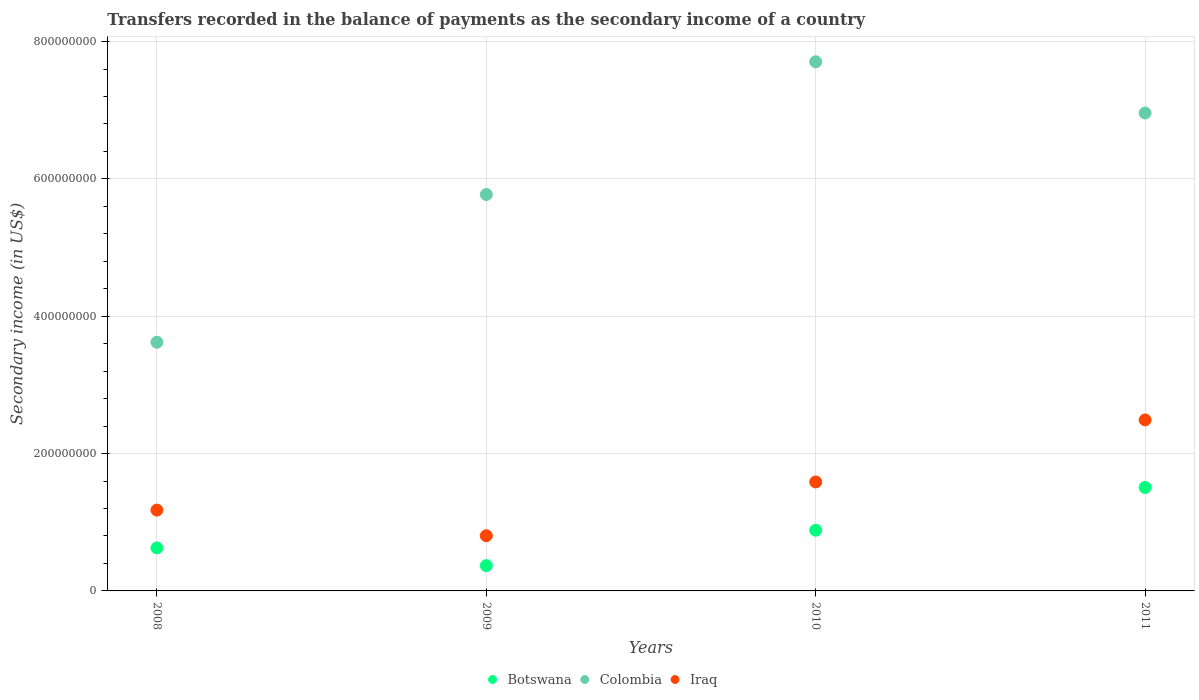Is the number of dotlines equal to the number of legend labels?
Offer a very short reply. Yes. What is the secondary income of in Botswana in 2008?
Your response must be concise. 6.26e+07. Across all years, what is the maximum secondary income of in Colombia?
Offer a terse response. 7.71e+08. Across all years, what is the minimum secondary income of in Iraq?
Your answer should be compact. 8.04e+07. In which year was the secondary income of in Botswana maximum?
Give a very brief answer. 2011. In which year was the secondary income of in Botswana minimum?
Ensure brevity in your answer.  2009. What is the total secondary income of in Iraq in the graph?
Provide a succinct answer. 6.06e+08. What is the difference between the secondary income of in Iraq in 2008 and that in 2010?
Offer a very short reply. -4.10e+07. What is the difference between the secondary income of in Colombia in 2011 and the secondary income of in Botswana in 2010?
Keep it short and to the point. 6.07e+08. What is the average secondary income of in Botswana per year?
Ensure brevity in your answer.  8.46e+07. In the year 2008, what is the difference between the secondary income of in Colombia and secondary income of in Botswana?
Offer a terse response. 3.00e+08. What is the ratio of the secondary income of in Botswana in 2008 to that in 2010?
Provide a succinct answer. 0.71. What is the difference between the highest and the second highest secondary income of in Colombia?
Make the answer very short. 7.46e+07. What is the difference between the highest and the lowest secondary income of in Iraq?
Offer a terse response. 1.69e+08. In how many years, is the secondary income of in Iraq greater than the average secondary income of in Iraq taken over all years?
Offer a very short reply. 2. Is the sum of the secondary income of in Colombia in 2008 and 2011 greater than the maximum secondary income of in Botswana across all years?
Offer a very short reply. Yes. Does the secondary income of in Iraq monotonically increase over the years?
Offer a very short reply. No. How many dotlines are there?
Provide a succinct answer. 3. How many years are there in the graph?
Give a very brief answer. 4. What is the difference between two consecutive major ticks on the Y-axis?
Offer a terse response. 2.00e+08. Are the values on the major ticks of Y-axis written in scientific E-notation?
Your answer should be very brief. No. Does the graph contain any zero values?
Give a very brief answer. No. Where does the legend appear in the graph?
Your response must be concise. Bottom center. What is the title of the graph?
Offer a very short reply. Transfers recorded in the balance of payments as the secondary income of a country. Does "Iran" appear as one of the legend labels in the graph?
Your response must be concise. No. What is the label or title of the Y-axis?
Provide a short and direct response. Secondary income (in US$). What is the Secondary income (in US$) of Botswana in 2008?
Ensure brevity in your answer.  6.26e+07. What is the Secondary income (in US$) of Colombia in 2008?
Keep it short and to the point. 3.62e+08. What is the Secondary income (in US$) in Iraq in 2008?
Your response must be concise. 1.18e+08. What is the Secondary income (in US$) in Botswana in 2009?
Provide a short and direct response. 3.68e+07. What is the Secondary income (in US$) of Colombia in 2009?
Your answer should be very brief. 5.77e+08. What is the Secondary income (in US$) of Iraq in 2009?
Your response must be concise. 8.04e+07. What is the Secondary income (in US$) of Botswana in 2010?
Keep it short and to the point. 8.84e+07. What is the Secondary income (in US$) in Colombia in 2010?
Your answer should be compact. 7.71e+08. What is the Secondary income (in US$) of Iraq in 2010?
Ensure brevity in your answer.  1.59e+08. What is the Secondary income (in US$) in Botswana in 2011?
Your answer should be very brief. 1.51e+08. What is the Secondary income (in US$) in Colombia in 2011?
Your answer should be compact. 6.96e+08. What is the Secondary income (in US$) in Iraq in 2011?
Make the answer very short. 2.49e+08. Across all years, what is the maximum Secondary income (in US$) of Botswana?
Offer a terse response. 1.51e+08. Across all years, what is the maximum Secondary income (in US$) in Colombia?
Provide a succinct answer. 7.71e+08. Across all years, what is the maximum Secondary income (in US$) in Iraq?
Your answer should be very brief. 2.49e+08. Across all years, what is the minimum Secondary income (in US$) of Botswana?
Ensure brevity in your answer.  3.68e+07. Across all years, what is the minimum Secondary income (in US$) in Colombia?
Offer a very short reply. 3.62e+08. Across all years, what is the minimum Secondary income (in US$) in Iraq?
Make the answer very short. 8.04e+07. What is the total Secondary income (in US$) in Botswana in the graph?
Your response must be concise. 3.39e+08. What is the total Secondary income (in US$) of Colombia in the graph?
Offer a very short reply. 2.41e+09. What is the total Secondary income (in US$) of Iraq in the graph?
Make the answer very short. 6.06e+08. What is the difference between the Secondary income (in US$) in Botswana in 2008 and that in 2009?
Ensure brevity in your answer.  2.58e+07. What is the difference between the Secondary income (in US$) in Colombia in 2008 and that in 2009?
Give a very brief answer. -2.15e+08. What is the difference between the Secondary income (in US$) of Iraq in 2008 and that in 2009?
Make the answer very short. 3.73e+07. What is the difference between the Secondary income (in US$) of Botswana in 2008 and that in 2010?
Your response must be concise. -2.58e+07. What is the difference between the Secondary income (in US$) of Colombia in 2008 and that in 2010?
Offer a terse response. -4.08e+08. What is the difference between the Secondary income (in US$) of Iraq in 2008 and that in 2010?
Your answer should be very brief. -4.10e+07. What is the difference between the Secondary income (in US$) of Botswana in 2008 and that in 2011?
Ensure brevity in your answer.  -8.80e+07. What is the difference between the Secondary income (in US$) in Colombia in 2008 and that in 2011?
Provide a succinct answer. -3.34e+08. What is the difference between the Secondary income (in US$) in Iraq in 2008 and that in 2011?
Ensure brevity in your answer.  -1.31e+08. What is the difference between the Secondary income (in US$) in Botswana in 2009 and that in 2010?
Your response must be concise. -5.16e+07. What is the difference between the Secondary income (in US$) in Colombia in 2009 and that in 2010?
Give a very brief answer. -1.93e+08. What is the difference between the Secondary income (in US$) in Iraq in 2009 and that in 2010?
Ensure brevity in your answer.  -7.83e+07. What is the difference between the Secondary income (in US$) of Botswana in 2009 and that in 2011?
Provide a short and direct response. -1.14e+08. What is the difference between the Secondary income (in US$) of Colombia in 2009 and that in 2011?
Your answer should be very brief. -1.19e+08. What is the difference between the Secondary income (in US$) in Iraq in 2009 and that in 2011?
Offer a very short reply. -1.69e+08. What is the difference between the Secondary income (in US$) of Botswana in 2010 and that in 2011?
Provide a succinct answer. -6.22e+07. What is the difference between the Secondary income (in US$) in Colombia in 2010 and that in 2011?
Your answer should be very brief. 7.46e+07. What is the difference between the Secondary income (in US$) of Iraq in 2010 and that in 2011?
Make the answer very short. -9.03e+07. What is the difference between the Secondary income (in US$) of Botswana in 2008 and the Secondary income (in US$) of Colombia in 2009?
Make the answer very short. -5.15e+08. What is the difference between the Secondary income (in US$) of Botswana in 2008 and the Secondary income (in US$) of Iraq in 2009?
Give a very brief answer. -1.78e+07. What is the difference between the Secondary income (in US$) in Colombia in 2008 and the Secondary income (in US$) in Iraq in 2009?
Keep it short and to the point. 2.82e+08. What is the difference between the Secondary income (in US$) in Botswana in 2008 and the Secondary income (in US$) in Colombia in 2010?
Offer a very short reply. -7.08e+08. What is the difference between the Secondary income (in US$) in Botswana in 2008 and the Secondary income (in US$) in Iraq in 2010?
Provide a succinct answer. -9.61e+07. What is the difference between the Secondary income (in US$) in Colombia in 2008 and the Secondary income (in US$) in Iraq in 2010?
Ensure brevity in your answer.  2.03e+08. What is the difference between the Secondary income (in US$) of Botswana in 2008 and the Secondary income (in US$) of Colombia in 2011?
Ensure brevity in your answer.  -6.33e+08. What is the difference between the Secondary income (in US$) in Botswana in 2008 and the Secondary income (in US$) in Iraq in 2011?
Give a very brief answer. -1.86e+08. What is the difference between the Secondary income (in US$) of Colombia in 2008 and the Secondary income (in US$) of Iraq in 2011?
Your answer should be compact. 1.13e+08. What is the difference between the Secondary income (in US$) of Botswana in 2009 and the Secondary income (in US$) of Colombia in 2010?
Provide a short and direct response. -7.34e+08. What is the difference between the Secondary income (in US$) in Botswana in 2009 and the Secondary income (in US$) in Iraq in 2010?
Provide a short and direct response. -1.22e+08. What is the difference between the Secondary income (in US$) in Colombia in 2009 and the Secondary income (in US$) in Iraq in 2010?
Your response must be concise. 4.19e+08. What is the difference between the Secondary income (in US$) in Botswana in 2009 and the Secondary income (in US$) in Colombia in 2011?
Keep it short and to the point. -6.59e+08. What is the difference between the Secondary income (in US$) in Botswana in 2009 and the Secondary income (in US$) in Iraq in 2011?
Provide a short and direct response. -2.12e+08. What is the difference between the Secondary income (in US$) of Colombia in 2009 and the Secondary income (in US$) of Iraq in 2011?
Keep it short and to the point. 3.28e+08. What is the difference between the Secondary income (in US$) in Botswana in 2010 and the Secondary income (in US$) in Colombia in 2011?
Provide a succinct answer. -6.07e+08. What is the difference between the Secondary income (in US$) of Botswana in 2010 and the Secondary income (in US$) of Iraq in 2011?
Make the answer very short. -1.61e+08. What is the difference between the Secondary income (in US$) of Colombia in 2010 and the Secondary income (in US$) of Iraq in 2011?
Provide a short and direct response. 5.22e+08. What is the average Secondary income (in US$) of Botswana per year?
Make the answer very short. 8.46e+07. What is the average Secondary income (in US$) in Colombia per year?
Offer a very short reply. 6.01e+08. What is the average Secondary income (in US$) of Iraq per year?
Provide a succinct answer. 1.51e+08. In the year 2008, what is the difference between the Secondary income (in US$) of Botswana and Secondary income (in US$) of Colombia?
Ensure brevity in your answer.  -3.00e+08. In the year 2008, what is the difference between the Secondary income (in US$) in Botswana and Secondary income (in US$) in Iraq?
Your answer should be very brief. -5.51e+07. In the year 2008, what is the difference between the Secondary income (in US$) of Colombia and Secondary income (in US$) of Iraq?
Provide a succinct answer. 2.44e+08. In the year 2009, what is the difference between the Secondary income (in US$) of Botswana and Secondary income (in US$) of Colombia?
Ensure brevity in your answer.  -5.40e+08. In the year 2009, what is the difference between the Secondary income (in US$) of Botswana and Secondary income (in US$) of Iraq?
Give a very brief answer. -4.36e+07. In the year 2009, what is the difference between the Secondary income (in US$) in Colombia and Secondary income (in US$) in Iraq?
Your answer should be very brief. 4.97e+08. In the year 2010, what is the difference between the Secondary income (in US$) in Botswana and Secondary income (in US$) in Colombia?
Your answer should be very brief. -6.82e+08. In the year 2010, what is the difference between the Secondary income (in US$) of Botswana and Secondary income (in US$) of Iraq?
Your answer should be very brief. -7.03e+07. In the year 2010, what is the difference between the Secondary income (in US$) of Colombia and Secondary income (in US$) of Iraq?
Offer a very short reply. 6.12e+08. In the year 2011, what is the difference between the Secondary income (in US$) of Botswana and Secondary income (in US$) of Colombia?
Offer a terse response. -5.45e+08. In the year 2011, what is the difference between the Secondary income (in US$) of Botswana and Secondary income (in US$) of Iraq?
Make the answer very short. -9.83e+07. In the year 2011, what is the difference between the Secondary income (in US$) of Colombia and Secondary income (in US$) of Iraq?
Keep it short and to the point. 4.47e+08. What is the ratio of the Secondary income (in US$) of Botswana in 2008 to that in 2009?
Your answer should be compact. 1.7. What is the ratio of the Secondary income (in US$) of Colombia in 2008 to that in 2009?
Give a very brief answer. 0.63. What is the ratio of the Secondary income (in US$) in Iraq in 2008 to that in 2009?
Provide a short and direct response. 1.46. What is the ratio of the Secondary income (in US$) in Botswana in 2008 to that in 2010?
Give a very brief answer. 0.71. What is the ratio of the Secondary income (in US$) in Colombia in 2008 to that in 2010?
Your answer should be very brief. 0.47. What is the ratio of the Secondary income (in US$) of Iraq in 2008 to that in 2010?
Offer a very short reply. 0.74. What is the ratio of the Secondary income (in US$) in Botswana in 2008 to that in 2011?
Your answer should be very brief. 0.42. What is the ratio of the Secondary income (in US$) in Colombia in 2008 to that in 2011?
Make the answer very short. 0.52. What is the ratio of the Secondary income (in US$) of Iraq in 2008 to that in 2011?
Provide a short and direct response. 0.47. What is the ratio of the Secondary income (in US$) of Botswana in 2009 to that in 2010?
Offer a terse response. 0.42. What is the ratio of the Secondary income (in US$) of Colombia in 2009 to that in 2010?
Keep it short and to the point. 0.75. What is the ratio of the Secondary income (in US$) of Iraq in 2009 to that in 2010?
Offer a terse response. 0.51. What is the ratio of the Secondary income (in US$) of Botswana in 2009 to that in 2011?
Provide a short and direct response. 0.24. What is the ratio of the Secondary income (in US$) in Colombia in 2009 to that in 2011?
Provide a short and direct response. 0.83. What is the ratio of the Secondary income (in US$) of Iraq in 2009 to that in 2011?
Your response must be concise. 0.32. What is the ratio of the Secondary income (in US$) of Botswana in 2010 to that in 2011?
Provide a short and direct response. 0.59. What is the ratio of the Secondary income (in US$) in Colombia in 2010 to that in 2011?
Ensure brevity in your answer.  1.11. What is the ratio of the Secondary income (in US$) of Iraq in 2010 to that in 2011?
Your answer should be very brief. 0.64. What is the difference between the highest and the second highest Secondary income (in US$) in Botswana?
Ensure brevity in your answer.  6.22e+07. What is the difference between the highest and the second highest Secondary income (in US$) in Colombia?
Your answer should be very brief. 7.46e+07. What is the difference between the highest and the second highest Secondary income (in US$) in Iraq?
Your answer should be very brief. 9.03e+07. What is the difference between the highest and the lowest Secondary income (in US$) of Botswana?
Keep it short and to the point. 1.14e+08. What is the difference between the highest and the lowest Secondary income (in US$) in Colombia?
Give a very brief answer. 4.08e+08. What is the difference between the highest and the lowest Secondary income (in US$) of Iraq?
Provide a short and direct response. 1.69e+08. 